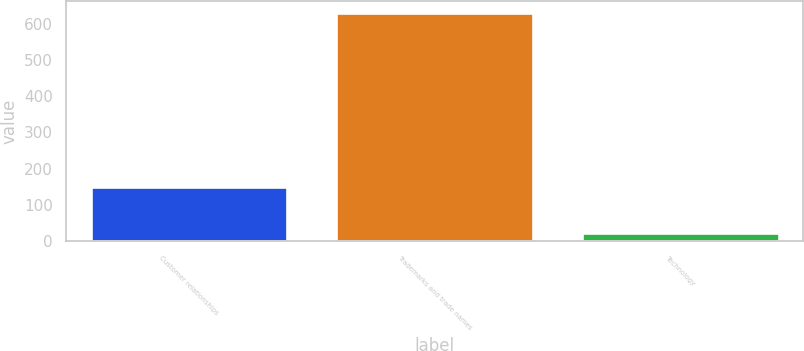Convert chart to OTSL. <chart><loc_0><loc_0><loc_500><loc_500><bar_chart><fcel>Customer relationships<fcel>Trademarks and trade names<fcel>Technology<nl><fcel>148.9<fcel>630.2<fcel>22.2<nl></chart> 